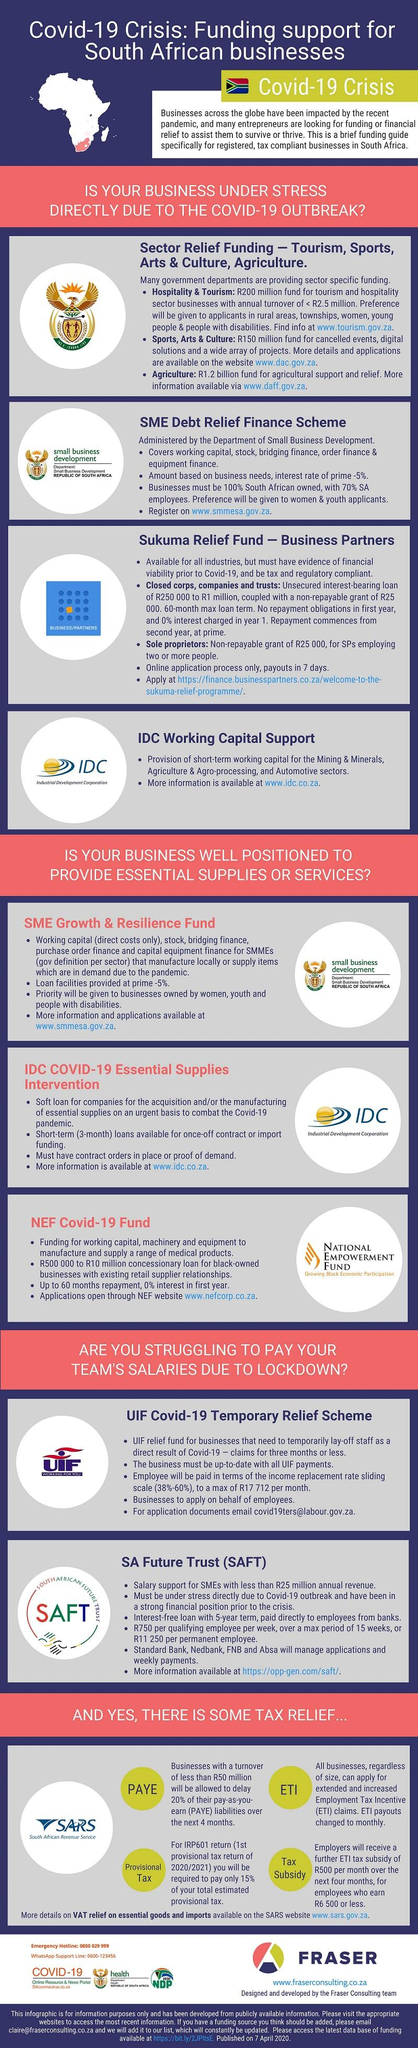Specify some key components in this picture. There are two points under the heading "IDC Working Capital Support." The heading "SME Growth & Resilience Fund" contains a total of 4 points. 